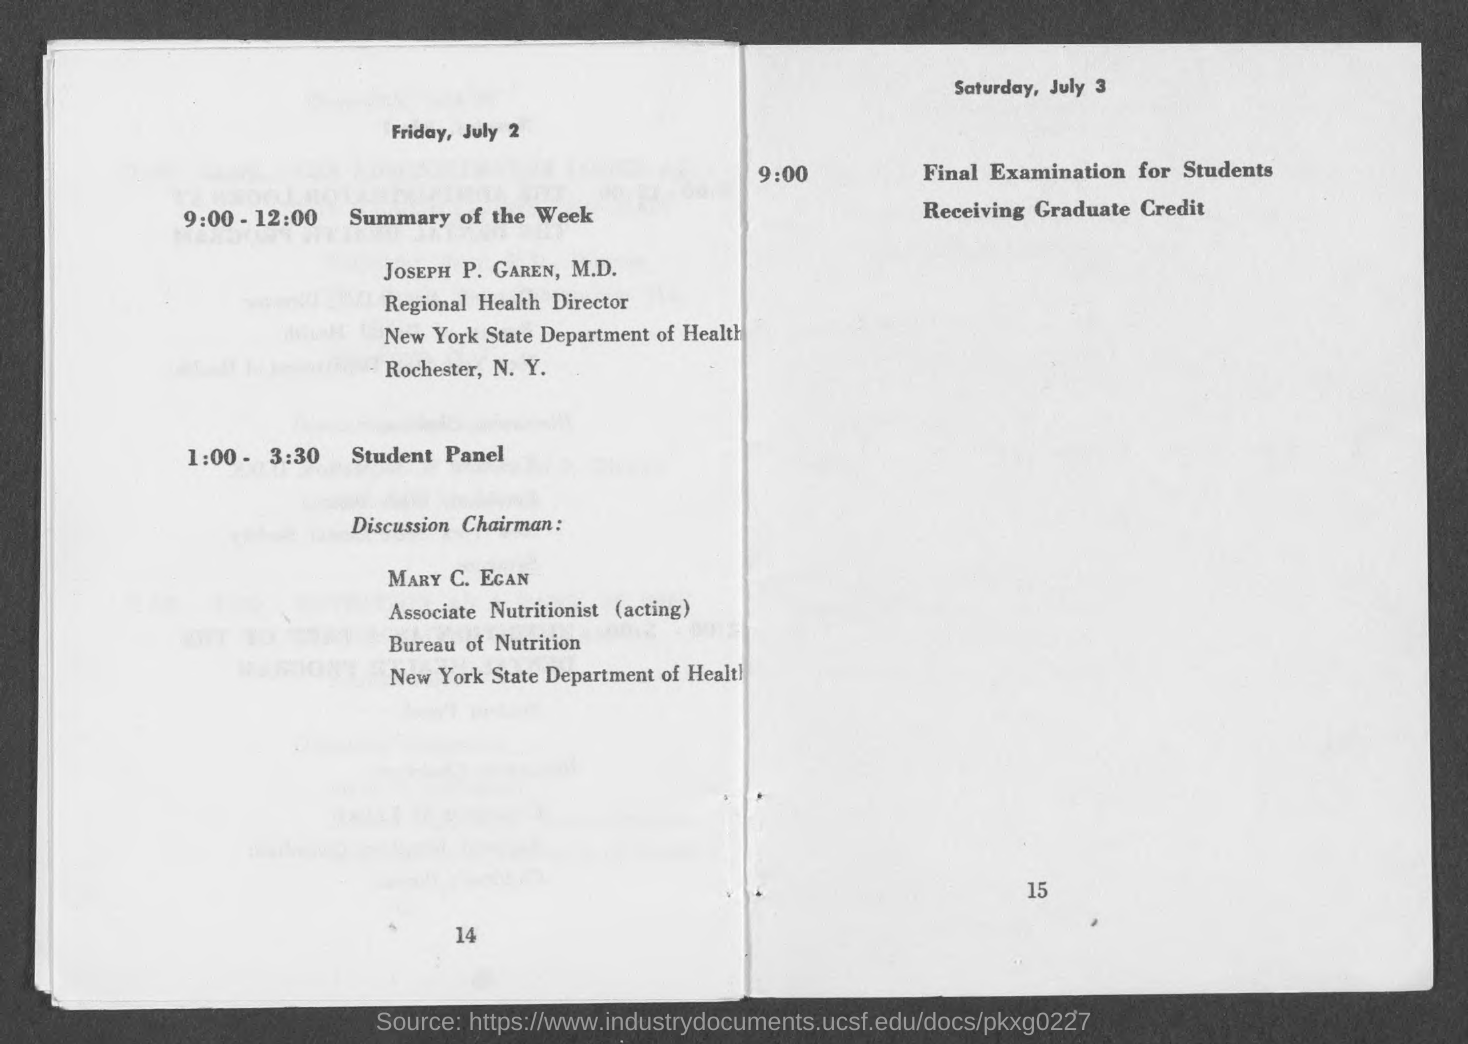Who will present the Summary of the Week?
Your answer should be compact. Joseph P. Garen. Who is the Discussion Chairman for the student panel?
Offer a terse response. Mary C. Egan. When is the final examination for students receiving graduate credit?
Provide a short and direct response. Saturday, July 3. 